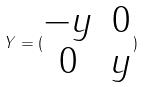Convert formula to latex. <formula><loc_0><loc_0><loc_500><loc_500>Y = ( \begin{matrix} - y & 0 \\ 0 & y \end{matrix} )</formula> 